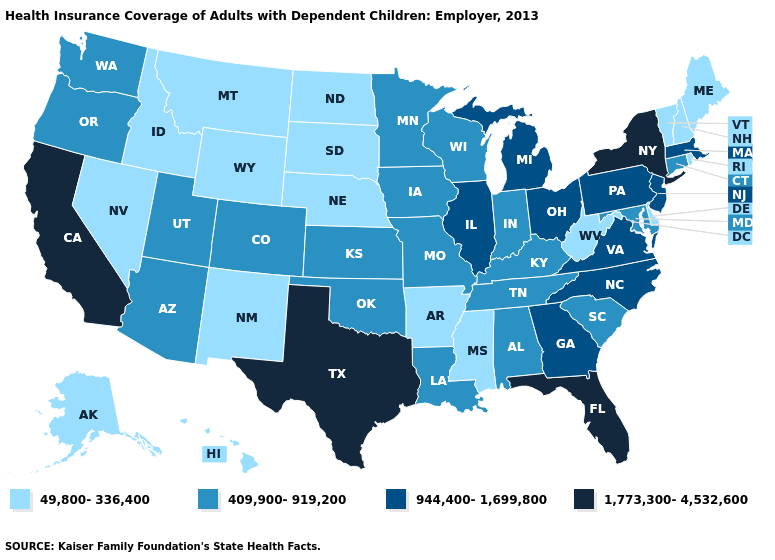Name the states that have a value in the range 944,400-1,699,800?
Be succinct. Georgia, Illinois, Massachusetts, Michigan, New Jersey, North Carolina, Ohio, Pennsylvania, Virginia. What is the lowest value in the Northeast?
Be succinct. 49,800-336,400. Name the states that have a value in the range 944,400-1,699,800?
Keep it brief. Georgia, Illinois, Massachusetts, Michigan, New Jersey, North Carolina, Ohio, Pennsylvania, Virginia. What is the value of Kentucky?
Write a very short answer. 409,900-919,200. Does Vermont have the highest value in the Northeast?
Concise answer only. No. Name the states that have a value in the range 409,900-919,200?
Keep it brief. Alabama, Arizona, Colorado, Connecticut, Indiana, Iowa, Kansas, Kentucky, Louisiana, Maryland, Minnesota, Missouri, Oklahoma, Oregon, South Carolina, Tennessee, Utah, Washington, Wisconsin. Among the states that border Oklahoma , which have the lowest value?
Quick response, please. Arkansas, New Mexico. Does Texas have the lowest value in the USA?
Concise answer only. No. What is the value of Arizona?
Give a very brief answer. 409,900-919,200. Name the states that have a value in the range 49,800-336,400?
Concise answer only. Alaska, Arkansas, Delaware, Hawaii, Idaho, Maine, Mississippi, Montana, Nebraska, Nevada, New Hampshire, New Mexico, North Dakota, Rhode Island, South Dakota, Vermont, West Virginia, Wyoming. Which states hav the highest value in the South?
Answer briefly. Florida, Texas. What is the lowest value in the USA?
Answer briefly. 49,800-336,400. What is the value of Florida?
Short answer required. 1,773,300-4,532,600. Does California have the same value as Florida?
Concise answer only. Yes. 